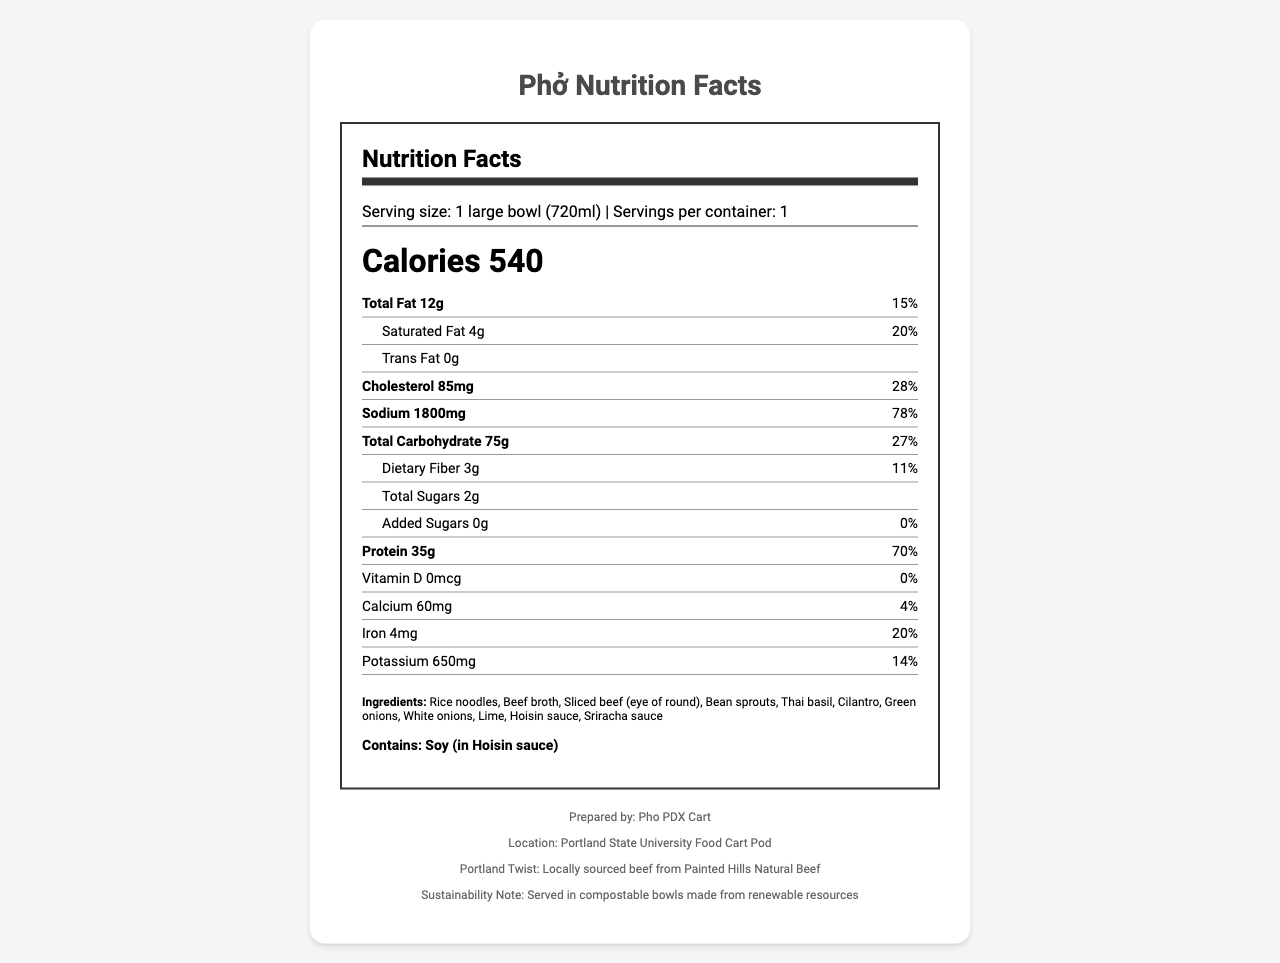what is the serving size for this Phở? The serving size information is clearly stated near the top of the Nutrition Facts section of the document.
Answer: 1 large bowl (720ml) how many calories are in one serving? The calories are prominently displayed in the Nutrition Facts section.
Answer: 540 what is the dietary fiber content and its daily value percentage? The document lists the dietary fiber content as 3 grams and the daily value percentage as 11%.
Answer: 3g, 11% which ingredient in this Phở might cause an allergic reaction for some people? The allergens section specifies that soy, found in the Hoisin sauce, might cause an allergic reaction.
Answer: Soy how many grams of protein are in one serving of this Phở? The protein content is listed as 35 grams in the Nutrition Facts section.
Answer: 35g what is the location of the food cart? The footer contains information about the location, specifying that it is at the Portland State University Food Cart Pod.
Answer: Portland State University Food Cart Pod which nutrient has the highest daily value percentage? A. Sodium B. Total Fat C. Iron D. Protein Sodium has a daily value percentage of 78%, which is the highest among the listed nutrients.
Answer: A. Sodium what is the percentage of daily value for saturated fat in this Phở? A. 10% B. 15% C. 20% D. 25% The saturated fat content has a daily value percentage of 20%, which matches option C.
Answer: C. 20% is there any trans fat in this Phở? The Nutrition Facts state that there are 0 grams of trans fat in this Phở.
Answer: No does this Phở contain more than 1000mg of sodium per serving? The sodium content is 1800mg, which is more than 1000mg.
Answer: Yes summarize the main nutritional characteristics of this Phở The summary encapsulates the core nutritional data, highlighting significant macronutrient contents and potential allergens, providing a clear overview of the key nutritional information presented in the document.
Answer: This large bowl of traditional beef Phở contains 540 calories per serving, with significant amounts of protein (35g), carbohydrates (75g), and notable amounts of certain nutrients like sodium and cholesterol. It has minimal sugars and dietary fiber and contains soy as a potential allergen. what is the source of the beef used in this Phở? The document does not specify the exact source of the beef used, only that it is locally sourced from Painted Hills Natural Beef. Further details would be required to fully determine its origin.
Answer: Not enough information 